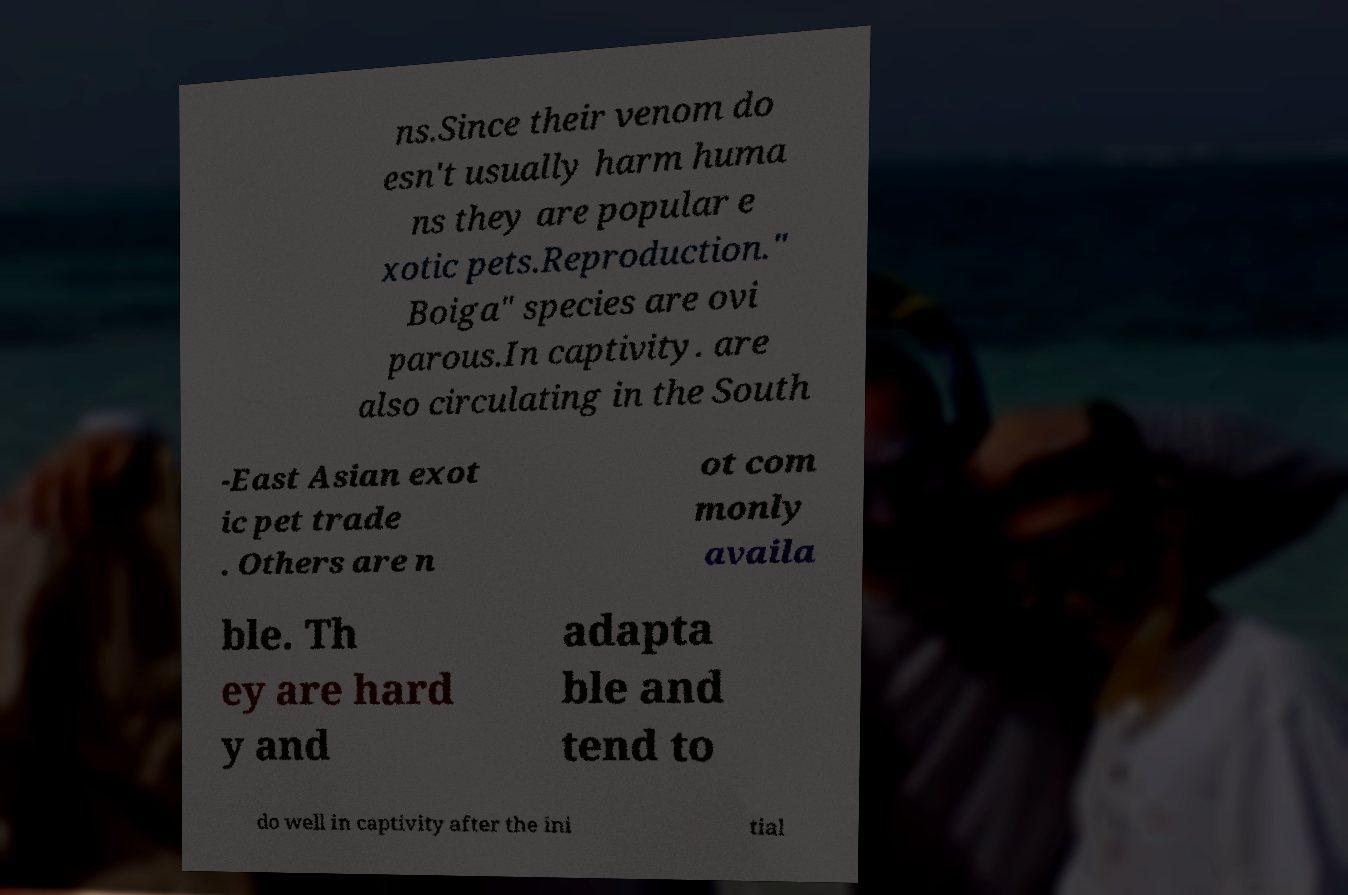Could you extract and type out the text from this image? ns.Since their venom do esn't usually harm huma ns they are popular e xotic pets.Reproduction." Boiga" species are ovi parous.In captivity. are also circulating in the South -East Asian exot ic pet trade . Others are n ot com monly availa ble. Th ey are hard y and adapta ble and tend to do well in captivity after the ini tial 